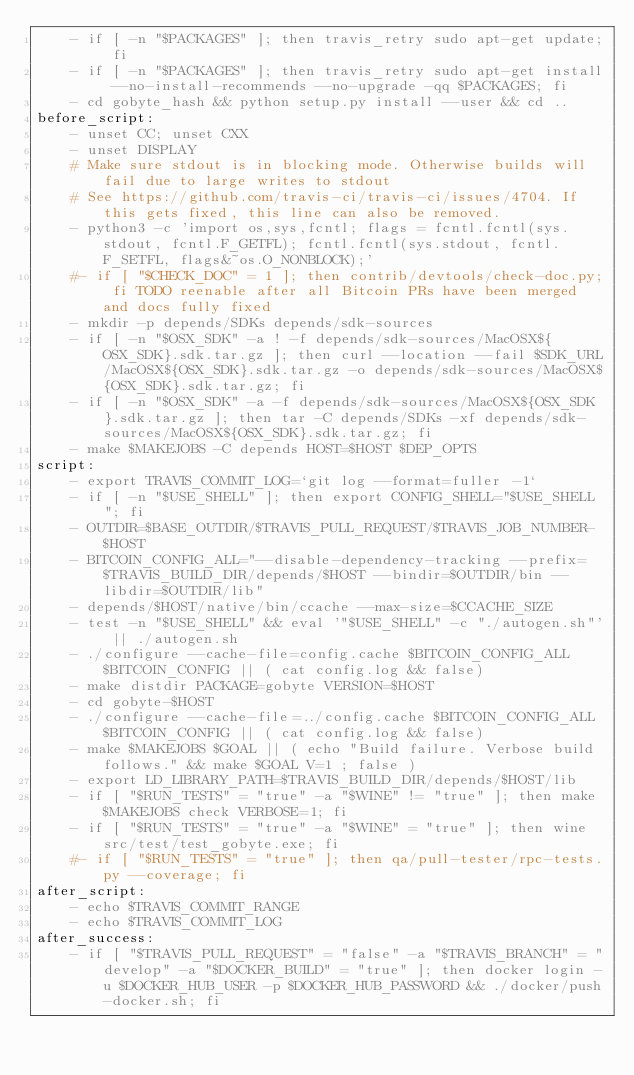<code> <loc_0><loc_0><loc_500><loc_500><_YAML_>    - if [ -n "$PACKAGES" ]; then travis_retry sudo apt-get update; fi
    - if [ -n "$PACKAGES" ]; then travis_retry sudo apt-get install --no-install-recommends --no-upgrade -qq $PACKAGES; fi
    - cd gobyte_hash && python setup.py install --user && cd ..
before_script:
    - unset CC; unset CXX
    - unset DISPLAY
    # Make sure stdout is in blocking mode. Otherwise builds will fail due to large writes to stdout
    # See https://github.com/travis-ci/travis-ci/issues/4704. If this gets fixed, this line can also be removed.
    - python3 -c 'import os,sys,fcntl; flags = fcntl.fcntl(sys.stdout, fcntl.F_GETFL); fcntl.fcntl(sys.stdout, fcntl.F_SETFL, flags&~os.O_NONBLOCK);'
    #- if [ "$CHECK_DOC" = 1 ]; then contrib/devtools/check-doc.py; fi TODO reenable after all Bitcoin PRs have been merged and docs fully fixed
    - mkdir -p depends/SDKs depends/sdk-sources
    - if [ -n "$OSX_SDK" -a ! -f depends/sdk-sources/MacOSX${OSX_SDK}.sdk.tar.gz ]; then curl --location --fail $SDK_URL/MacOSX${OSX_SDK}.sdk.tar.gz -o depends/sdk-sources/MacOSX${OSX_SDK}.sdk.tar.gz; fi
    - if [ -n "$OSX_SDK" -a -f depends/sdk-sources/MacOSX${OSX_SDK}.sdk.tar.gz ]; then tar -C depends/SDKs -xf depends/sdk-sources/MacOSX${OSX_SDK}.sdk.tar.gz; fi
    - make $MAKEJOBS -C depends HOST=$HOST $DEP_OPTS
script:
    - export TRAVIS_COMMIT_LOG=`git log --format=fuller -1`
    - if [ -n "$USE_SHELL" ]; then export CONFIG_SHELL="$USE_SHELL"; fi
    - OUTDIR=$BASE_OUTDIR/$TRAVIS_PULL_REQUEST/$TRAVIS_JOB_NUMBER-$HOST
    - BITCOIN_CONFIG_ALL="--disable-dependency-tracking --prefix=$TRAVIS_BUILD_DIR/depends/$HOST --bindir=$OUTDIR/bin --libdir=$OUTDIR/lib"
    - depends/$HOST/native/bin/ccache --max-size=$CCACHE_SIZE
    - test -n "$USE_SHELL" && eval '"$USE_SHELL" -c "./autogen.sh"' || ./autogen.sh
    - ./configure --cache-file=config.cache $BITCOIN_CONFIG_ALL $BITCOIN_CONFIG || ( cat config.log && false)
    - make distdir PACKAGE=gobyte VERSION=$HOST
    - cd gobyte-$HOST
    - ./configure --cache-file=../config.cache $BITCOIN_CONFIG_ALL $BITCOIN_CONFIG || ( cat config.log && false)
    - make $MAKEJOBS $GOAL || ( echo "Build failure. Verbose build follows." && make $GOAL V=1 ; false )
    - export LD_LIBRARY_PATH=$TRAVIS_BUILD_DIR/depends/$HOST/lib
    - if [ "$RUN_TESTS" = "true" -a "$WINE" != "true" ]; then make $MAKEJOBS check VERBOSE=1; fi
    - if [ "$RUN_TESTS" = "true" -a "$WINE" = "true" ]; then wine  src/test/test_gobyte.exe; fi
    #- if [ "$RUN_TESTS" = "true" ]; then qa/pull-tester/rpc-tests.py --coverage; fi
after_script:
    - echo $TRAVIS_COMMIT_RANGE
    - echo $TRAVIS_COMMIT_LOG
after_success:
    - if [ "$TRAVIS_PULL_REQUEST" = "false" -a "$TRAVIS_BRANCH" = "develop" -a "$DOCKER_BUILD" = "true" ]; then docker login -u $DOCKER_HUB_USER -p $DOCKER_HUB_PASSWORD && ./docker/push-docker.sh; fi
</code> 